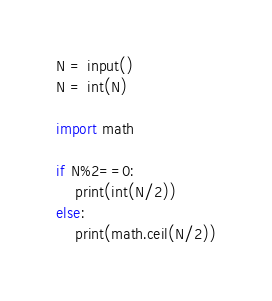<code> <loc_0><loc_0><loc_500><loc_500><_Python_>N = input()
N = int(N)

import math

if N%2==0:
    print(int(N/2))
else:
    print(math.ceil(N/2))</code> 